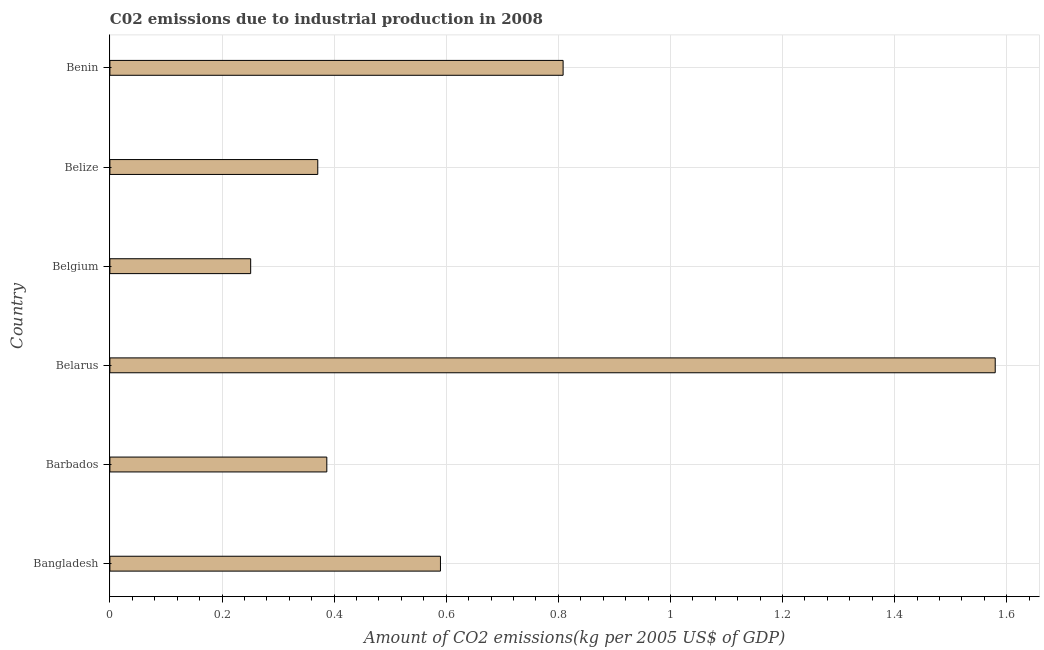Does the graph contain any zero values?
Give a very brief answer. No. Does the graph contain grids?
Keep it short and to the point. Yes. What is the title of the graph?
Offer a very short reply. C02 emissions due to industrial production in 2008. What is the label or title of the X-axis?
Offer a very short reply. Amount of CO2 emissions(kg per 2005 US$ of GDP). What is the label or title of the Y-axis?
Keep it short and to the point. Country. What is the amount of co2 emissions in Belarus?
Provide a short and direct response. 1.58. Across all countries, what is the maximum amount of co2 emissions?
Your answer should be very brief. 1.58. Across all countries, what is the minimum amount of co2 emissions?
Provide a short and direct response. 0.25. In which country was the amount of co2 emissions maximum?
Provide a short and direct response. Belarus. In which country was the amount of co2 emissions minimum?
Your response must be concise. Belgium. What is the sum of the amount of co2 emissions?
Make the answer very short. 3.99. What is the difference between the amount of co2 emissions in Belarus and Belgium?
Your answer should be very brief. 1.33. What is the average amount of co2 emissions per country?
Your answer should be compact. 0.66. What is the median amount of co2 emissions?
Provide a succinct answer. 0.49. What is the ratio of the amount of co2 emissions in Belize to that in Benin?
Offer a very short reply. 0.46. Is the amount of co2 emissions in Belize less than that in Benin?
Give a very brief answer. Yes. What is the difference between the highest and the second highest amount of co2 emissions?
Your answer should be compact. 0.77. Is the sum of the amount of co2 emissions in Belarus and Belize greater than the maximum amount of co2 emissions across all countries?
Offer a very short reply. Yes. What is the difference between the highest and the lowest amount of co2 emissions?
Your answer should be very brief. 1.33. How many countries are there in the graph?
Your response must be concise. 6. What is the Amount of CO2 emissions(kg per 2005 US$ of GDP) in Bangladesh?
Ensure brevity in your answer.  0.59. What is the Amount of CO2 emissions(kg per 2005 US$ of GDP) of Barbados?
Your answer should be compact. 0.39. What is the Amount of CO2 emissions(kg per 2005 US$ of GDP) of Belarus?
Ensure brevity in your answer.  1.58. What is the Amount of CO2 emissions(kg per 2005 US$ of GDP) of Belgium?
Your answer should be very brief. 0.25. What is the Amount of CO2 emissions(kg per 2005 US$ of GDP) of Belize?
Your answer should be compact. 0.37. What is the Amount of CO2 emissions(kg per 2005 US$ of GDP) of Benin?
Your answer should be compact. 0.81. What is the difference between the Amount of CO2 emissions(kg per 2005 US$ of GDP) in Bangladesh and Barbados?
Provide a short and direct response. 0.2. What is the difference between the Amount of CO2 emissions(kg per 2005 US$ of GDP) in Bangladesh and Belarus?
Provide a short and direct response. -0.99. What is the difference between the Amount of CO2 emissions(kg per 2005 US$ of GDP) in Bangladesh and Belgium?
Provide a succinct answer. 0.34. What is the difference between the Amount of CO2 emissions(kg per 2005 US$ of GDP) in Bangladesh and Belize?
Your answer should be very brief. 0.22. What is the difference between the Amount of CO2 emissions(kg per 2005 US$ of GDP) in Bangladesh and Benin?
Your answer should be compact. -0.22. What is the difference between the Amount of CO2 emissions(kg per 2005 US$ of GDP) in Barbados and Belarus?
Your answer should be compact. -1.19. What is the difference between the Amount of CO2 emissions(kg per 2005 US$ of GDP) in Barbados and Belgium?
Provide a short and direct response. 0.14. What is the difference between the Amount of CO2 emissions(kg per 2005 US$ of GDP) in Barbados and Belize?
Keep it short and to the point. 0.02. What is the difference between the Amount of CO2 emissions(kg per 2005 US$ of GDP) in Barbados and Benin?
Offer a terse response. -0.42. What is the difference between the Amount of CO2 emissions(kg per 2005 US$ of GDP) in Belarus and Belgium?
Make the answer very short. 1.33. What is the difference between the Amount of CO2 emissions(kg per 2005 US$ of GDP) in Belarus and Belize?
Your response must be concise. 1.21. What is the difference between the Amount of CO2 emissions(kg per 2005 US$ of GDP) in Belarus and Benin?
Give a very brief answer. 0.77. What is the difference between the Amount of CO2 emissions(kg per 2005 US$ of GDP) in Belgium and Belize?
Ensure brevity in your answer.  -0.12. What is the difference between the Amount of CO2 emissions(kg per 2005 US$ of GDP) in Belgium and Benin?
Give a very brief answer. -0.56. What is the difference between the Amount of CO2 emissions(kg per 2005 US$ of GDP) in Belize and Benin?
Offer a very short reply. -0.44. What is the ratio of the Amount of CO2 emissions(kg per 2005 US$ of GDP) in Bangladesh to that in Barbados?
Keep it short and to the point. 1.52. What is the ratio of the Amount of CO2 emissions(kg per 2005 US$ of GDP) in Bangladesh to that in Belarus?
Offer a very short reply. 0.37. What is the ratio of the Amount of CO2 emissions(kg per 2005 US$ of GDP) in Bangladesh to that in Belgium?
Give a very brief answer. 2.35. What is the ratio of the Amount of CO2 emissions(kg per 2005 US$ of GDP) in Bangladesh to that in Belize?
Provide a succinct answer. 1.59. What is the ratio of the Amount of CO2 emissions(kg per 2005 US$ of GDP) in Bangladesh to that in Benin?
Your response must be concise. 0.73. What is the ratio of the Amount of CO2 emissions(kg per 2005 US$ of GDP) in Barbados to that in Belarus?
Provide a succinct answer. 0.24. What is the ratio of the Amount of CO2 emissions(kg per 2005 US$ of GDP) in Barbados to that in Belgium?
Give a very brief answer. 1.54. What is the ratio of the Amount of CO2 emissions(kg per 2005 US$ of GDP) in Barbados to that in Belize?
Keep it short and to the point. 1.04. What is the ratio of the Amount of CO2 emissions(kg per 2005 US$ of GDP) in Barbados to that in Benin?
Provide a short and direct response. 0.48. What is the ratio of the Amount of CO2 emissions(kg per 2005 US$ of GDP) in Belarus to that in Belgium?
Your answer should be compact. 6.29. What is the ratio of the Amount of CO2 emissions(kg per 2005 US$ of GDP) in Belarus to that in Belize?
Make the answer very short. 4.26. What is the ratio of the Amount of CO2 emissions(kg per 2005 US$ of GDP) in Belarus to that in Benin?
Offer a very short reply. 1.95. What is the ratio of the Amount of CO2 emissions(kg per 2005 US$ of GDP) in Belgium to that in Belize?
Offer a terse response. 0.68. What is the ratio of the Amount of CO2 emissions(kg per 2005 US$ of GDP) in Belgium to that in Benin?
Your answer should be very brief. 0.31. What is the ratio of the Amount of CO2 emissions(kg per 2005 US$ of GDP) in Belize to that in Benin?
Ensure brevity in your answer.  0.46. 